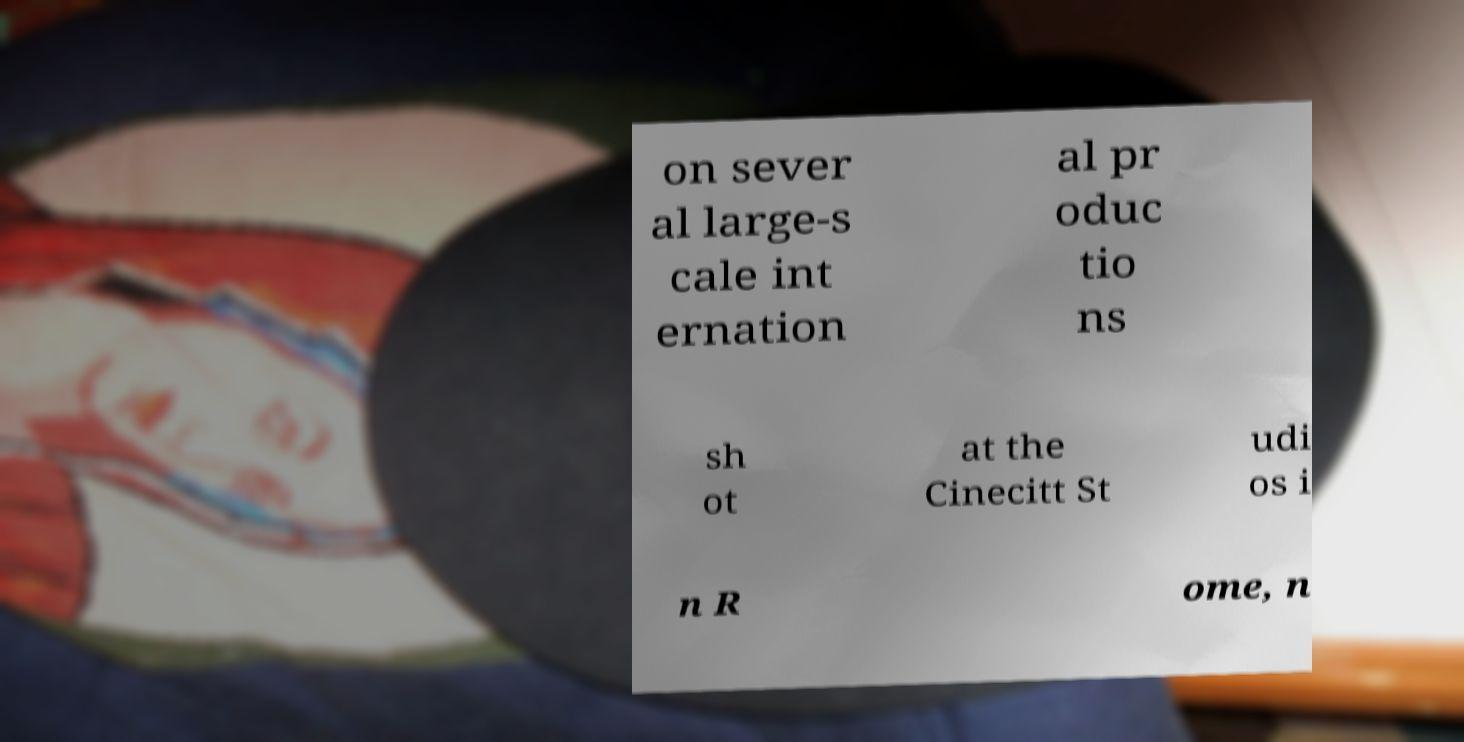Could you extract and type out the text from this image? on sever al large-s cale int ernation al pr oduc tio ns sh ot at the Cinecitt St udi os i n R ome, n 